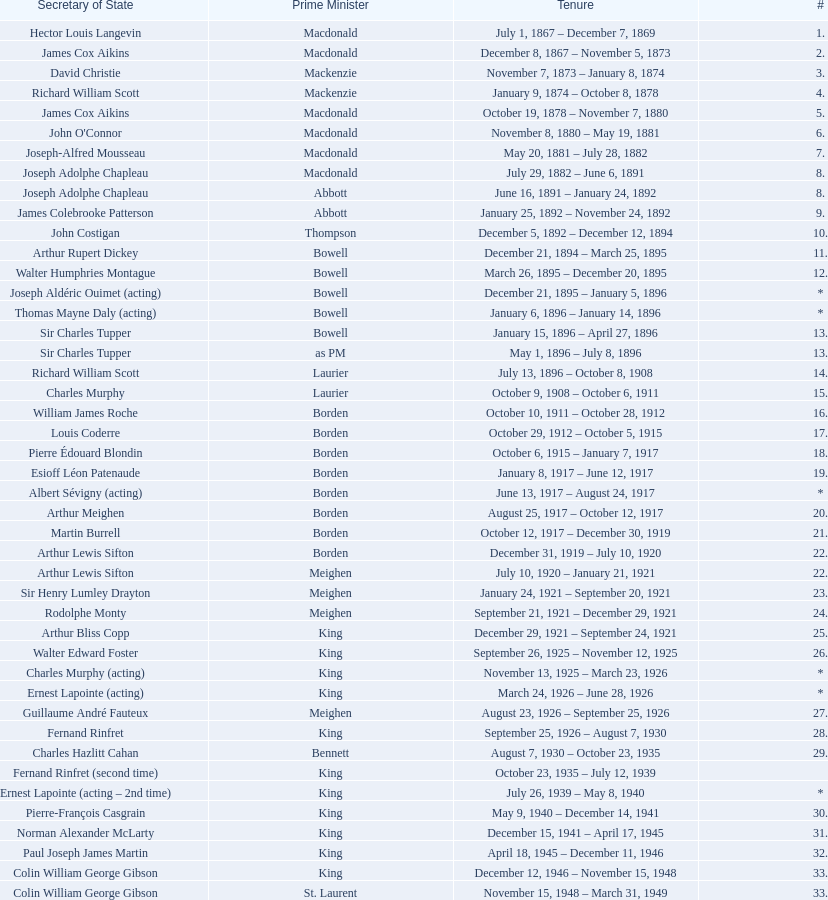Was macdonald prime minister before or after bowell? Before. 